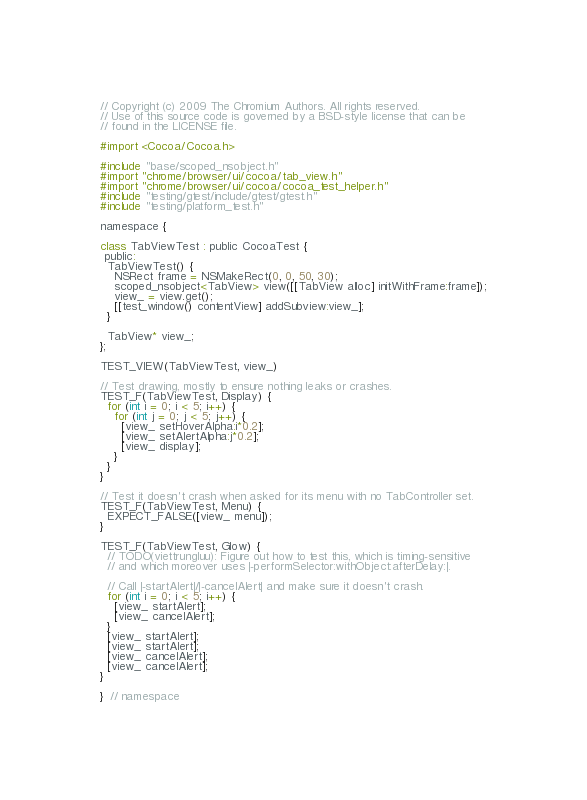Convert code to text. <code><loc_0><loc_0><loc_500><loc_500><_ObjectiveC_>// Copyright (c) 2009 The Chromium Authors. All rights reserved.
// Use of this source code is governed by a BSD-style license that can be
// found in the LICENSE file.

#import <Cocoa/Cocoa.h>

#include "base/scoped_nsobject.h"
#import "chrome/browser/ui/cocoa/tab_view.h"
#import "chrome/browser/ui/cocoa/cocoa_test_helper.h"
#include "testing/gtest/include/gtest/gtest.h"
#include "testing/platform_test.h"

namespace {

class TabViewTest : public CocoaTest {
 public:
  TabViewTest() {
    NSRect frame = NSMakeRect(0, 0, 50, 30);
    scoped_nsobject<TabView> view([[TabView alloc] initWithFrame:frame]);
    view_ = view.get();
    [[test_window() contentView] addSubview:view_];
  }

  TabView* view_;
};

TEST_VIEW(TabViewTest, view_)

// Test drawing, mostly to ensure nothing leaks or crashes.
TEST_F(TabViewTest, Display) {
  for (int i = 0; i < 5; i++) {
    for (int j = 0; j < 5; j++) {
      [view_ setHoverAlpha:i*0.2];
      [view_ setAlertAlpha:j*0.2];
      [view_ display];
    }
  }
}

// Test it doesn't crash when asked for its menu with no TabController set.
TEST_F(TabViewTest, Menu) {
  EXPECT_FALSE([view_ menu]);
}

TEST_F(TabViewTest, Glow) {
  // TODO(viettrungluu): Figure out how to test this, which is timing-sensitive
  // and which moreover uses |-performSelector:withObject:afterDelay:|.

  // Call |-startAlert|/|-cancelAlert| and make sure it doesn't crash.
  for (int i = 0; i < 5; i++) {
    [view_ startAlert];
    [view_ cancelAlert];
  }
  [view_ startAlert];
  [view_ startAlert];
  [view_ cancelAlert];
  [view_ cancelAlert];
}

}  // namespace
</code> 